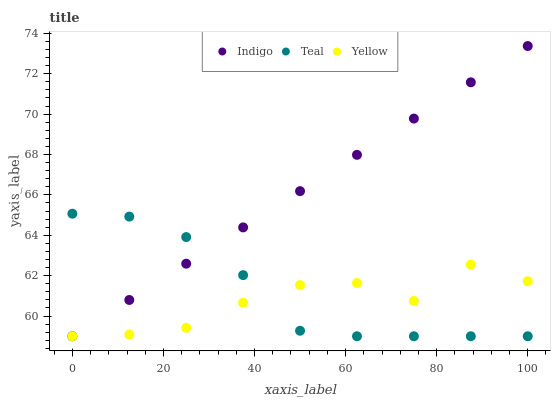Does Yellow have the minimum area under the curve?
Answer yes or no. Yes. Does Indigo have the maximum area under the curve?
Answer yes or no. Yes. Does Teal have the minimum area under the curve?
Answer yes or no. No. Does Teal have the maximum area under the curve?
Answer yes or no. No. Is Indigo the smoothest?
Answer yes or no. Yes. Is Yellow the roughest?
Answer yes or no. Yes. Is Teal the smoothest?
Answer yes or no. No. Is Teal the roughest?
Answer yes or no. No. Does Indigo have the lowest value?
Answer yes or no. Yes. Does Indigo have the highest value?
Answer yes or no. Yes. Does Teal have the highest value?
Answer yes or no. No. Does Teal intersect Yellow?
Answer yes or no. Yes. Is Teal less than Yellow?
Answer yes or no. No. Is Teal greater than Yellow?
Answer yes or no. No. 